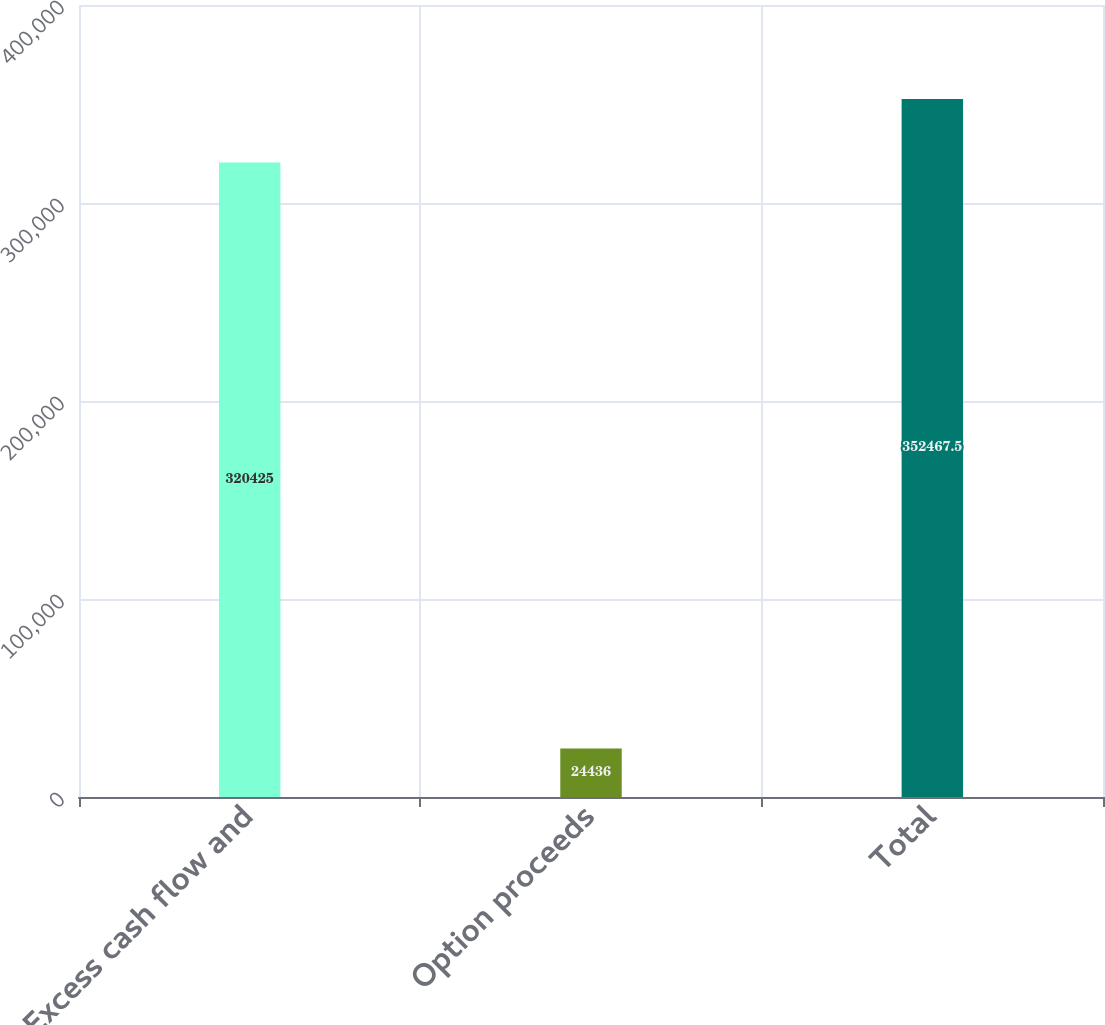Convert chart to OTSL. <chart><loc_0><loc_0><loc_500><loc_500><bar_chart><fcel>Excess cash flow and<fcel>Option proceeds<fcel>Total<nl><fcel>320425<fcel>24436<fcel>352468<nl></chart> 